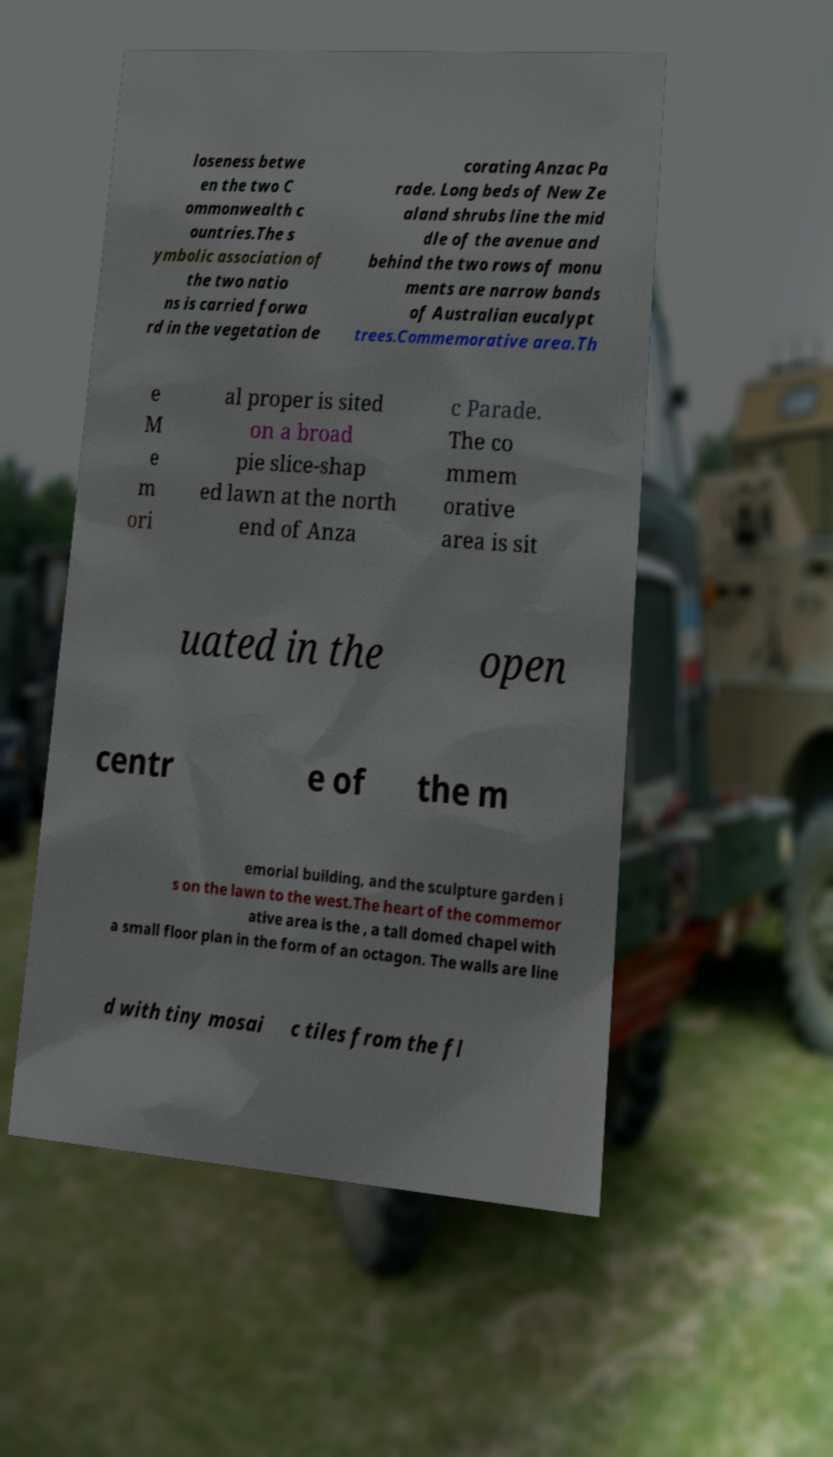I need the written content from this picture converted into text. Can you do that? loseness betwe en the two C ommonwealth c ountries.The s ymbolic association of the two natio ns is carried forwa rd in the vegetation de corating Anzac Pa rade. Long beds of New Ze aland shrubs line the mid dle of the avenue and behind the two rows of monu ments are narrow bands of Australian eucalypt trees.Commemorative area.Th e M e m ori al proper is sited on a broad pie slice-shap ed lawn at the north end of Anza c Parade. The co mmem orative area is sit uated in the open centr e of the m emorial building, and the sculpture garden i s on the lawn to the west.The heart of the commemor ative area is the , a tall domed chapel with a small floor plan in the form of an octagon. The walls are line d with tiny mosai c tiles from the fl 